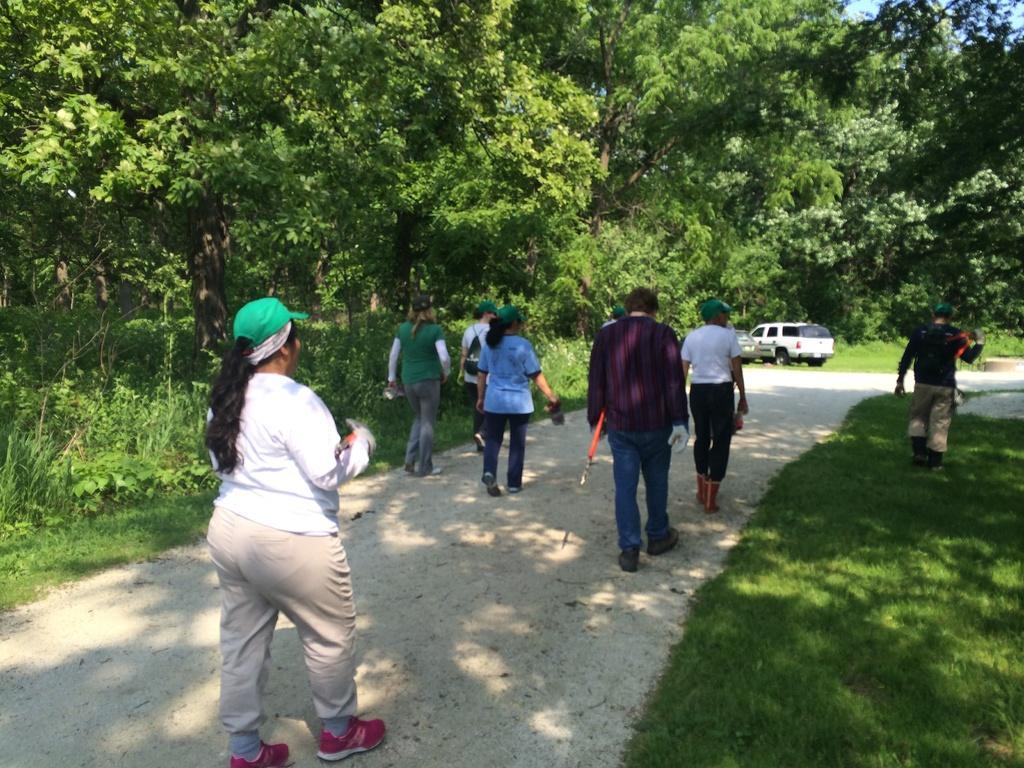In one or two sentences, can you explain what this image depicts? In the foreground of this image, there are persons moving on the road to which there are trees and grass on both the sides. In the background, there is a vehicle moving on the road. 